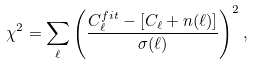<formula> <loc_0><loc_0><loc_500><loc_500>\chi ^ { 2 } = \sum _ { \ell } \left ( \frac { C ^ { f i t } _ { \ell } - [ C _ { \ell } + n ( \ell ) ] } { \sigma ( \ell ) } \right ) ^ { 2 } ,</formula> 